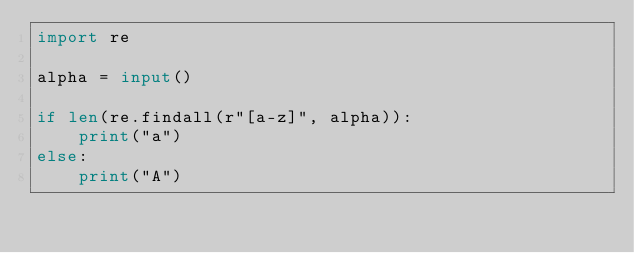<code> <loc_0><loc_0><loc_500><loc_500><_Python_>import re

alpha = input()

if len(re.findall(r"[a-z]", alpha)):
    print("a")
else:
    print("A")
</code> 